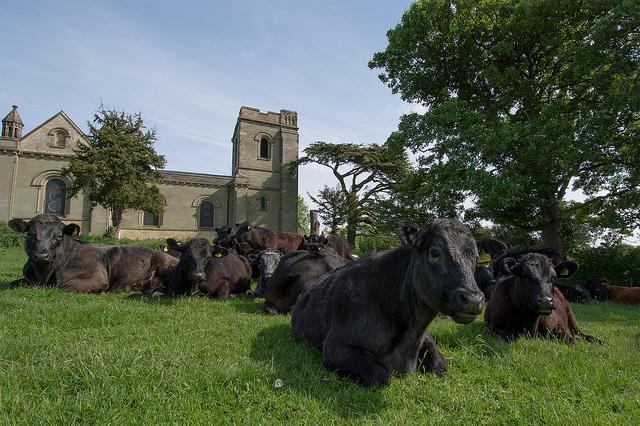How many cows can be seen?
Give a very brief answer. 5. 